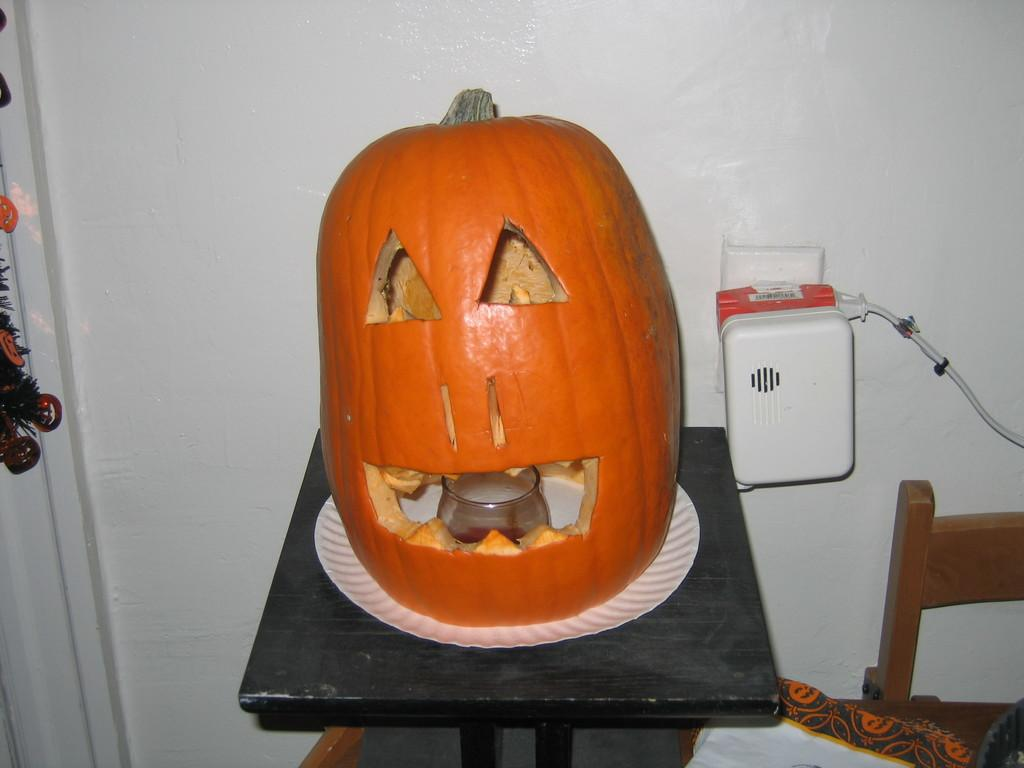What type of furniture is present in the image? There is a table and a chair in the image. What is placed on the table? There is a pumpkin on the table, and it is placed on a plate. What can be seen on the left side of the image? There are Christmas tree decorative items on the left side of the image. What type of selection process is being used to choose the women in the image? There are no women present in the image, so there is no selection process being used. 